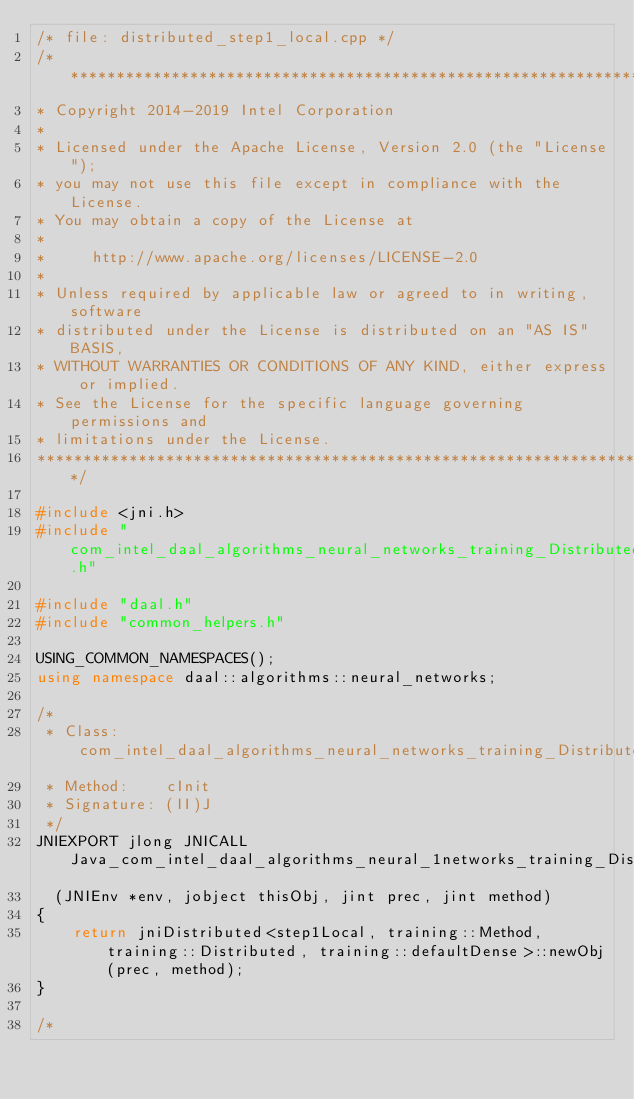Convert code to text. <code><loc_0><loc_0><loc_500><loc_500><_C++_>/* file: distributed_step1_local.cpp */
/*******************************************************************************
* Copyright 2014-2019 Intel Corporation
*
* Licensed under the Apache License, Version 2.0 (the "License");
* you may not use this file except in compliance with the License.
* You may obtain a copy of the License at
*
*     http://www.apache.org/licenses/LICENSE-2.0
*
* Unless required by applicable law or agreed to in writing, software
* distributed under the License is distributed on an "AS IS" BASIS,
* WITHOUT WARRANTIES OR CONDITIONS OF ANY KIND, either express or implied.
* See the License for the specific language governing permissions and
* limitations under the License.
*******************************************************************************/

#include <jni.h>
#include "com_intel_daal_algorithms_neural_networks_training_DistributedStep1Local.h"

#include "daal.h"
#include "common_helpers.h"

USING_COMMON_NAMESPACES();
using namespace daal::algorithms::neural_networks;

/*
 * Class:     com_intel_daal_algorithms_neural_networks_training_DistributedStep1Local
 * Method:    cInit
 * Signature: (II)J
 */
JNIEXPORT jlong JNICALL Java_com_intel_daal_algorithms_neural_1networks_training_DistributedStep1Local_cInit
  (JNIEnv *env, jobject thisObj, jint prec, jint method)
{
    return jniDistributed<step1Local, training::Method, training::Distributed, training::defaultDense>::newObj(prec, method);
}

/*</code> 